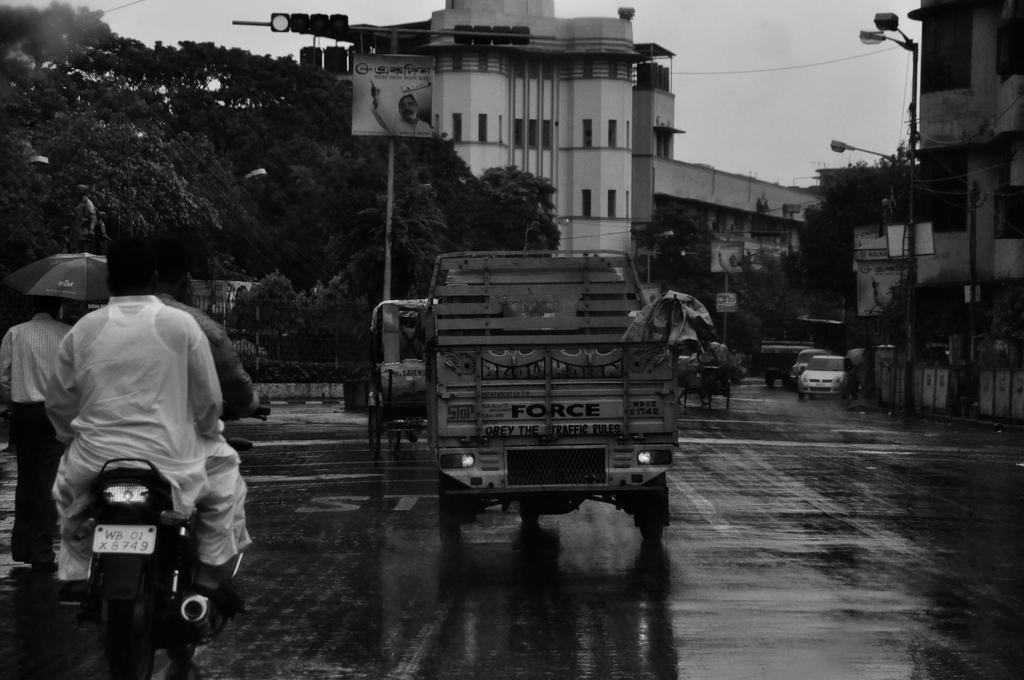How would you summarize this image in a sentence or two? It is the black and white image in which we can see that there is a road in the middle. On the road there are so many vehicles. On the left side there is a motorbike on which there are two persons. In the background there are buildings and trees beside them. In the middle of the road there is a traffic signal light. On the footpath there are electric poles with the lights. On the left side there is a person walking by holding an umbrella. 